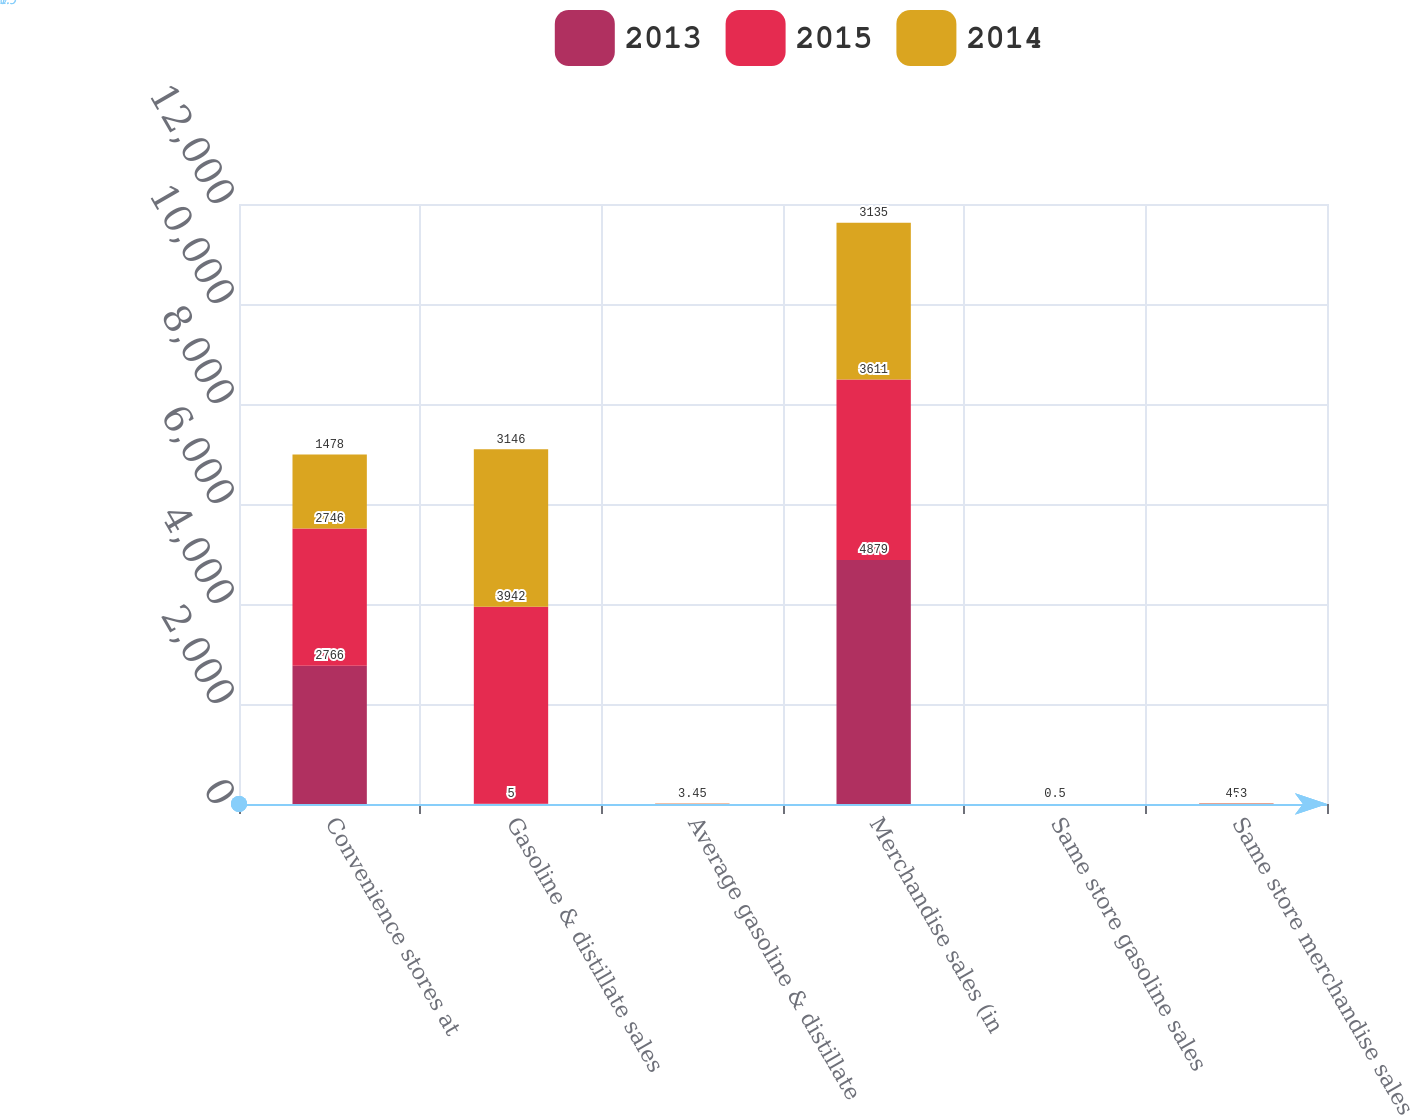<chart> <loc_0><loc_0><loc_500><loc_500><stacked_bar_chart><ecel><fcel>Convenience stores at<fcel>Gasoline & distillate sales<fcel>Average gasoline & distillate<fcel>Merchandise sales (in<fcel>Same store gasoline sales<fcel>Same store merchandise sales<nl><fcel>2013<fcel>2766<fcel>5<fcel>2.36<fcel>4879<fcel>0.3<fcel>4.1<nl><fcel>2015<fcel>2746<fcel>3942<fcel>3.25<fcel>3611<fcel>0.7<fcel>5<nl><fcel>2014<fcel>1478<fcel>3146<fcel>3.45<fcel>3135<fcel>0.5<fcel>4.3<nl></chart> 